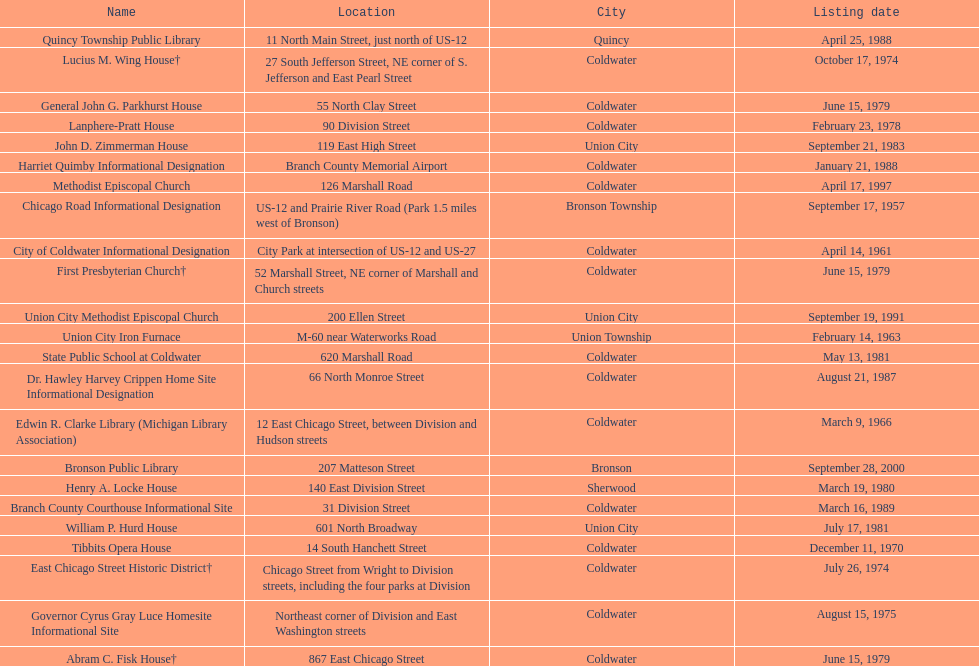How many sites are in coldwater? 15. 